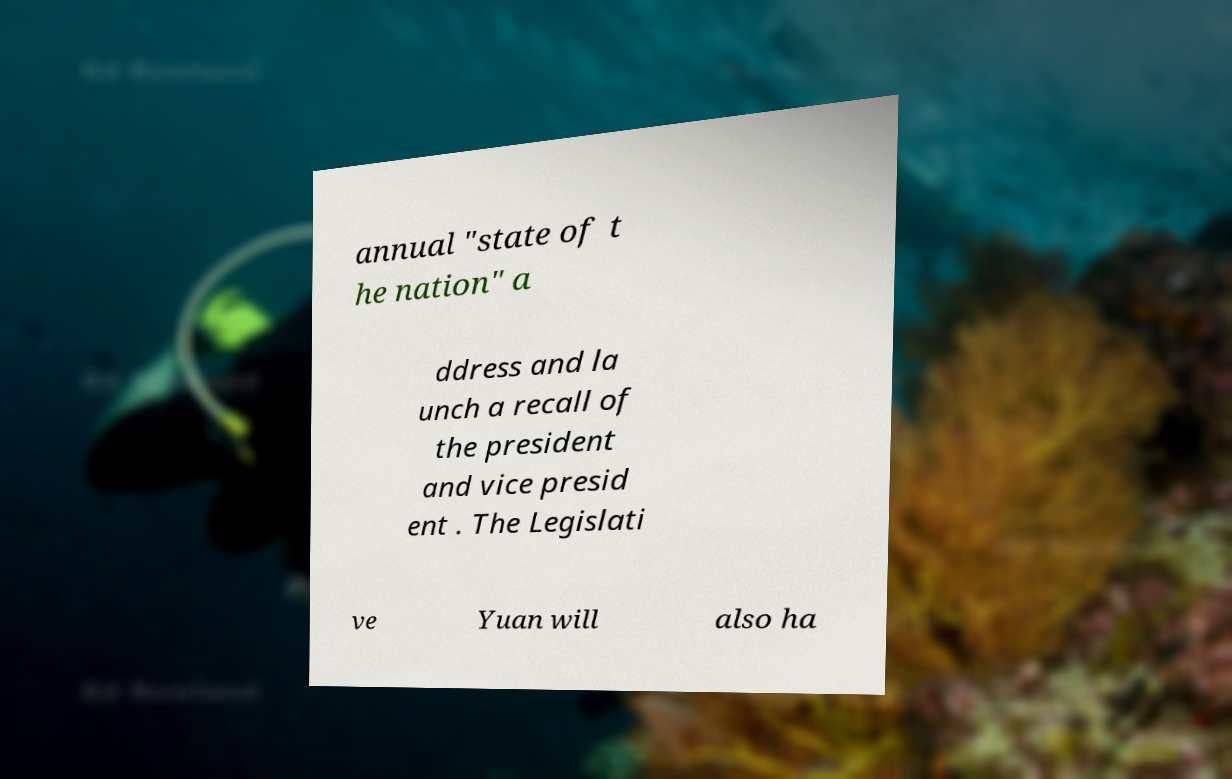There's text embedded in this image that I need extracted. Can you transcribe it verbatim? annual "state of t he nation" a ddress and la unch a recall of the president and vice presid ent . The Legislati ve Yuan will also ha 